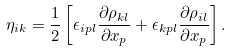<formula> <loc_0><loc_0><loc_500><loc_500>\eta _ { i k } = \frac { 1 } { 2 } \left [ \epsilon _ { i p l } \frac { \partial \rho _ { k l } } { \partial x _ { p } } + \epsilon _ { k p l } \frac { \partial \rho _ { i l } } { \partial x _ { p } } \right ] .</formula> 